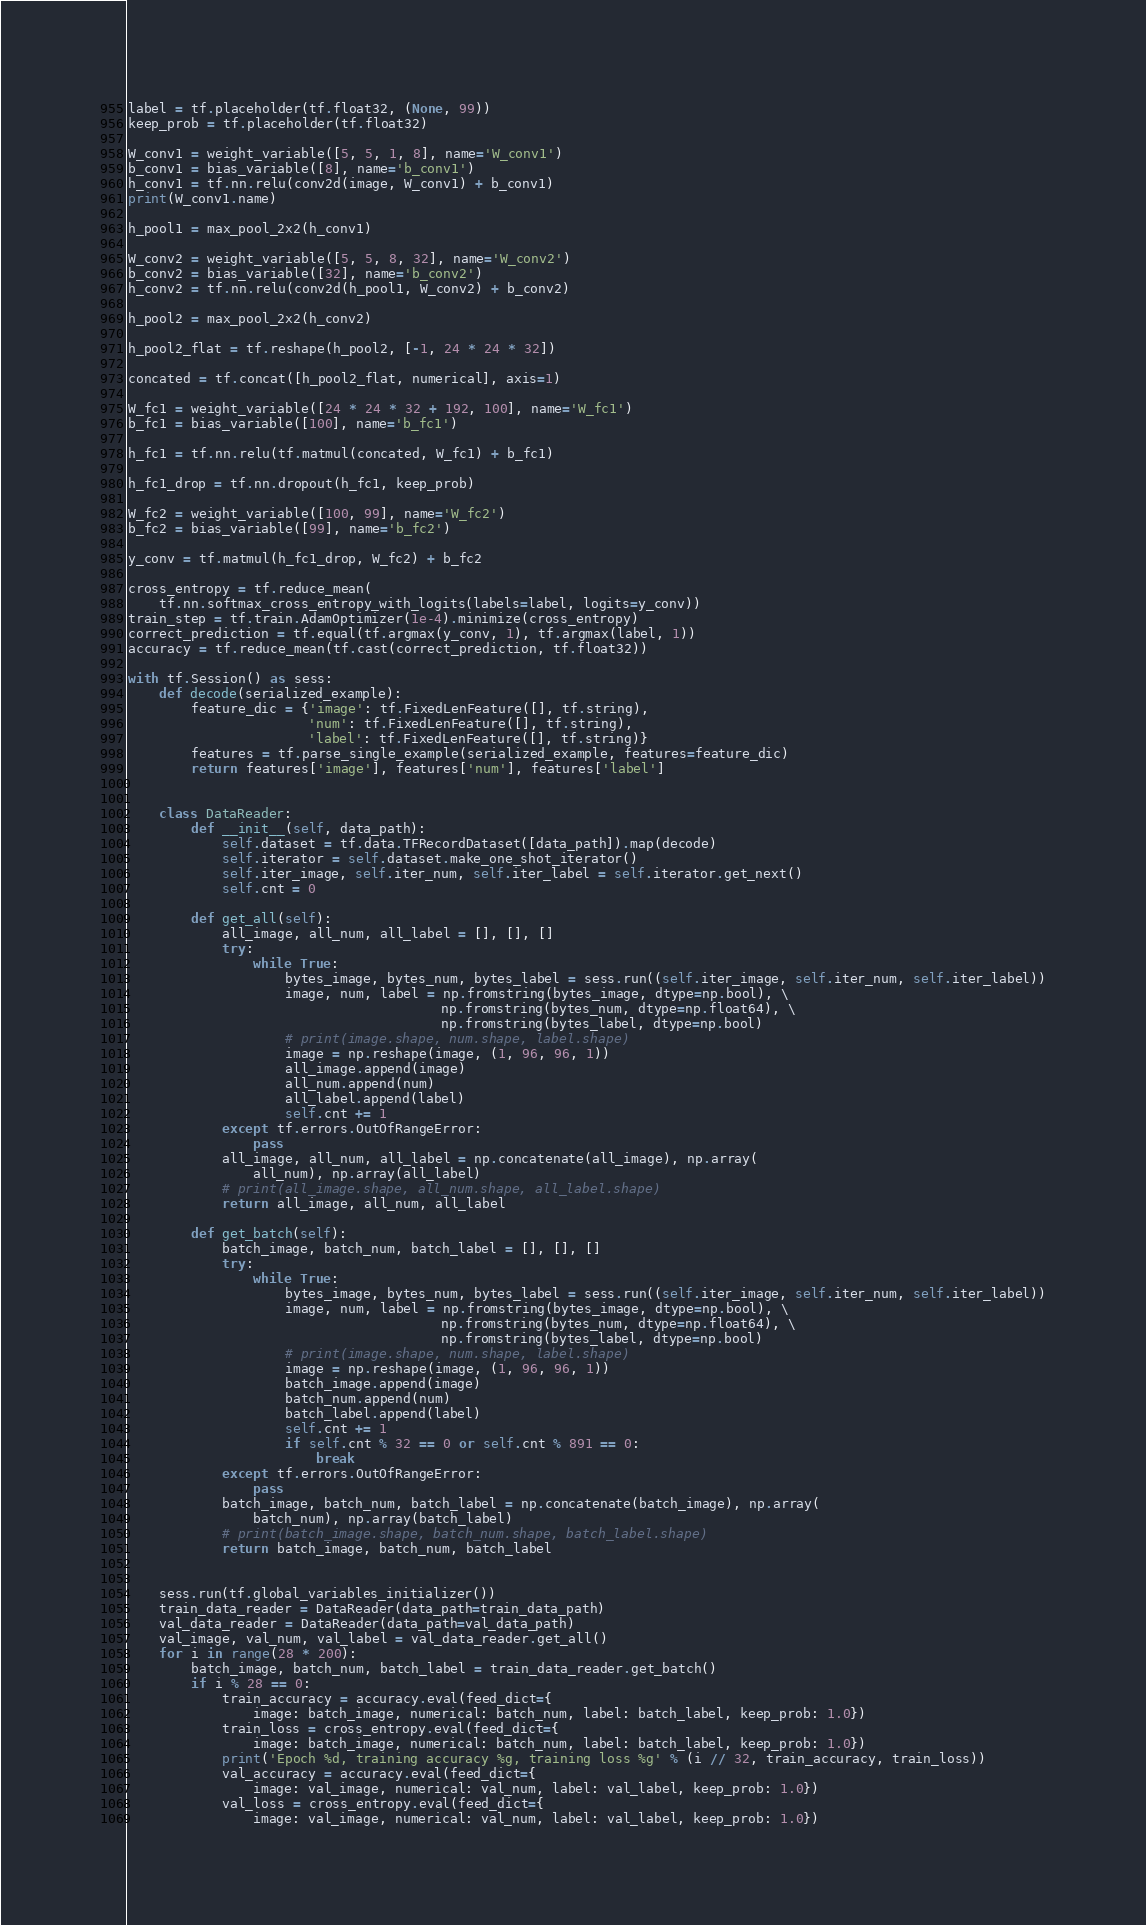Convert code to text. <code><loc_0><loc_0><loc_500><loc_500><_Python_>label = tf.placeholder(tf.float32, (None, 99))
keep_prob = tf.placeholder(tf.float32)

W_conv1 = weight_variable([5, 5, 1, 8], name='W_conv1')
b_conv1 = bias_variable([8], name='b_conv1')
h_conv1 = tf.nn.relu(conv2d(image, W_conv1) + b_conv1)
print(W_conv1.name)

h_pool1 = max_pool_2x2(h_conv1)

W_conv2 = weight_variable([5, 5, 8, 32], name='W_conv2')
b_conv2 = bias_variable([32], name='b_conv2')
h_conv2 = tf.nn.relu(conv2d(h_pool1, W_conv2) + b_conv2)

h_pool2 = max_pool_2x2(h_conv2)

h_pool2_flat = tf.reshape(h_pool2, [-1, 24 * 24 * 32])

concated = tf.concat([h_pool2_flat, numerical], axis=1)

W_fc1 = weight_variable([24 * 24 * 32 + 192, 100], name='W_fc1')
b_fc1 = bias_variable([100], name='b_fc1')

h_fc1 = tf.nn.relu(tf.matmul(concated, W_fc1) + b_fc1)

h_fc1_drop = tf.nn.dropout(h_fc1, keep_prob)

W_fc2 = weight_variable([100, 99], name='W_fc2')
b_fc2 = bias_variable([99], name='b_fc2')

y_conv = tf.matmul(h_fc1_drop, W_fc2) + b_fc2

cross_entropy = tf.reduce_mean(
    tf.nn.softmax_cross_entropy_with_logits(labels=label, logits=y_conv))
train_step = tf.train.AdamOptimizer(1e-4).minimize(cross_entropy)
correct_prediction = tf.equal(tf.argmax(y_conv, 1), tf.argmax(label, 1))
accuracy = tf.reduce_mean(tf.cast(correct_prediction, tf.float32))

with tf.Session() as sess:
    def decode(serialized_example):
        feature_dic = {'image': tf.FixedLenFeature([], tf.string),
                       'num': tf.FixedLenFeature([], tf.string),
                       'label': tf.FixedLenFeature([], tf.string)}
        features = tf.parse_single_example(serialized_example, features=feature_dic)
        return features['image'], features['num'], features['label']


    class DataReader:
        def __init__(self, data_path):
            self.dataset = tf.data.TFRecordDataset([data_path]).map(decode)
            self.iterator = self.dataset.make_one_shot_iterator()
            self.iter_image, self.iter_num, self.iter_label = self.iterator.get_next()
            self.cnt = 0

        def get_all(self):
            all_image, all_num, all_label = [], [], []
            try:
                while True:
                    bytes_image, bytes_num, bytes_label = sess.run((self.iter_image, self.iter_num, self.iter_label))
                    image, num, label = np.fromstring(bytes_image, dtype=np.bool), \
                                        np.fromstring(bytes_num, dtype=np.float64), \
                                        np.fromstring(bytes_label, dtype=np.bool)
                    # print(image.shape, num.shape, label.shape)
                    image = np.reshape(image, (1, 96, 96, 1))
                    all_image.append(image)
                    all_num.append(num)
                    all_label.append(label)
                    self.cnt += 1
            except tf.errors.OutOfRangeError:
                pass
            all_image, all_num, all_label = np.concatenate(all_image), np.array(
                all_num), np.array(all_label)
            # print(all_image.shape, all_num.shape, all_label.shape)
            return all_image, all_num, all_label

        def get_batch(self):
            batch_image, batch_num, batch_label = [], [], []
            try:
                while True:
                    bytes_image, bytes_num, bytes_label = sess.run((self.iter_image, self.iter_num, self.iter_label))
                    image, num, label = np.fromstring(bytes_image, dtype=np.bool), \
                                        np.fromstring(bytes_num, dtype=np.float64), \
                                        np.fromstring(bytes_label, dtype=np.bool)
                    # print(image.shape, num.shape, label.shape)
                    image = np.reshape(image, (1, 96, 96, 1))
                    batch_image.append(image)
                    batch_num.append(num)
                    batch_label.append(label)
                    self.cnt += 1
                    if self.cnt % 32 == 0 or self.cnt % 891 == 0:
                        break
            except tf.errors.OutOfRangeError:
                pass
            batch_image, batch_num, batch_label = np.concatenate(batch_image), np.array(
                batch_num), np.array(batch_label)
            # print(batch_image.shape, batch_num.shape, batch_label.shape)
            return batch_image, batch_num, batch_label


    sess.run(tf.global_variables_initializer())
    train_data_reader = DataReader(data_path=train_data_path)
    val_data_reader = DataReader(data_path=val_data_path)
    val_image, val_num, val_label = val_data_reader.get_all()
    for i in range(28 * 200):
        batch_image, batch_num, batch_label = train_data_reader.get_batch()
        if i % 28 == 0:
            train_accuracy = accuracy.eval(feed_dict={
                image: batch_image, numerical: batch_num, label: batch_label, keep_prob: 1.0})
            train_loss = cross_entropy.eval(feed_dict={
                image: batch_image, numerical: batch_num, label: batch_label, keep_prob: 1.0})
            print('Epoch %d, training accuracy %g, training loss %g' % (i // 32, train_accuracy, train_loss))
            val_accuracy = accuracy.eval(feed_dict={
                image: val_image, numerical: val_num, label: val_label, keep_prob: 1.0})
            val_loss = cross_entropy.eval(feed_dict={
                image: val_image, numerical: val_num, label: val_label, keep_prob: 1.0})</code> 